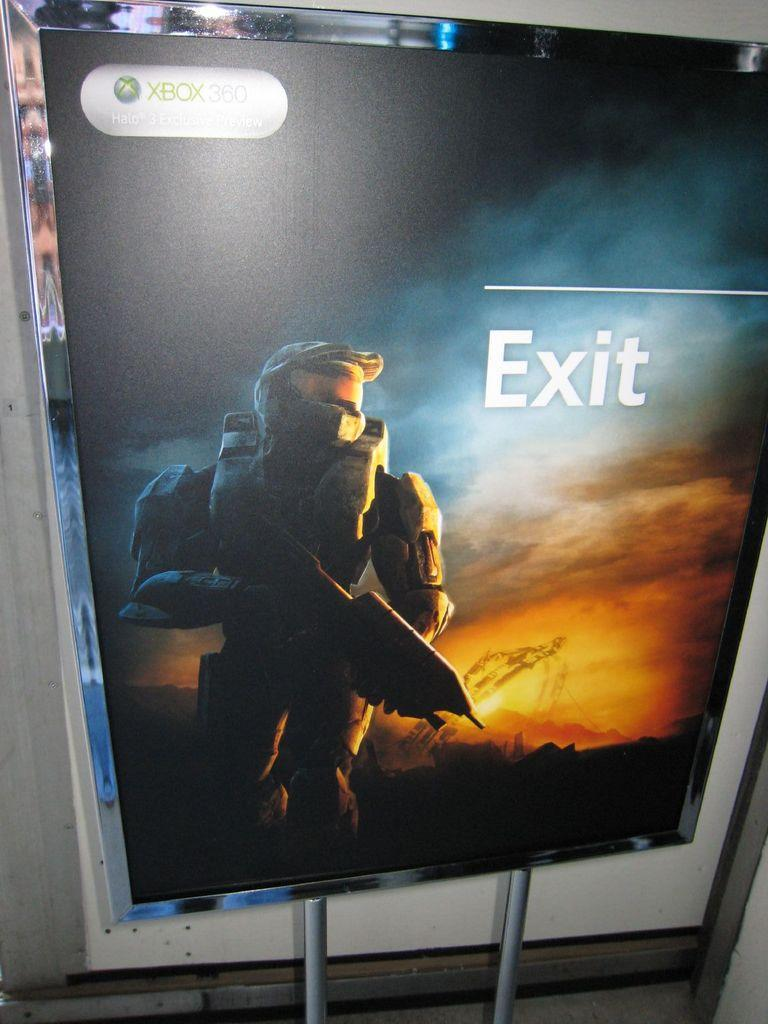<image>
Offer a succinct explanation of the picture presented. An xbox 360 poster that has the word Exit on it. 